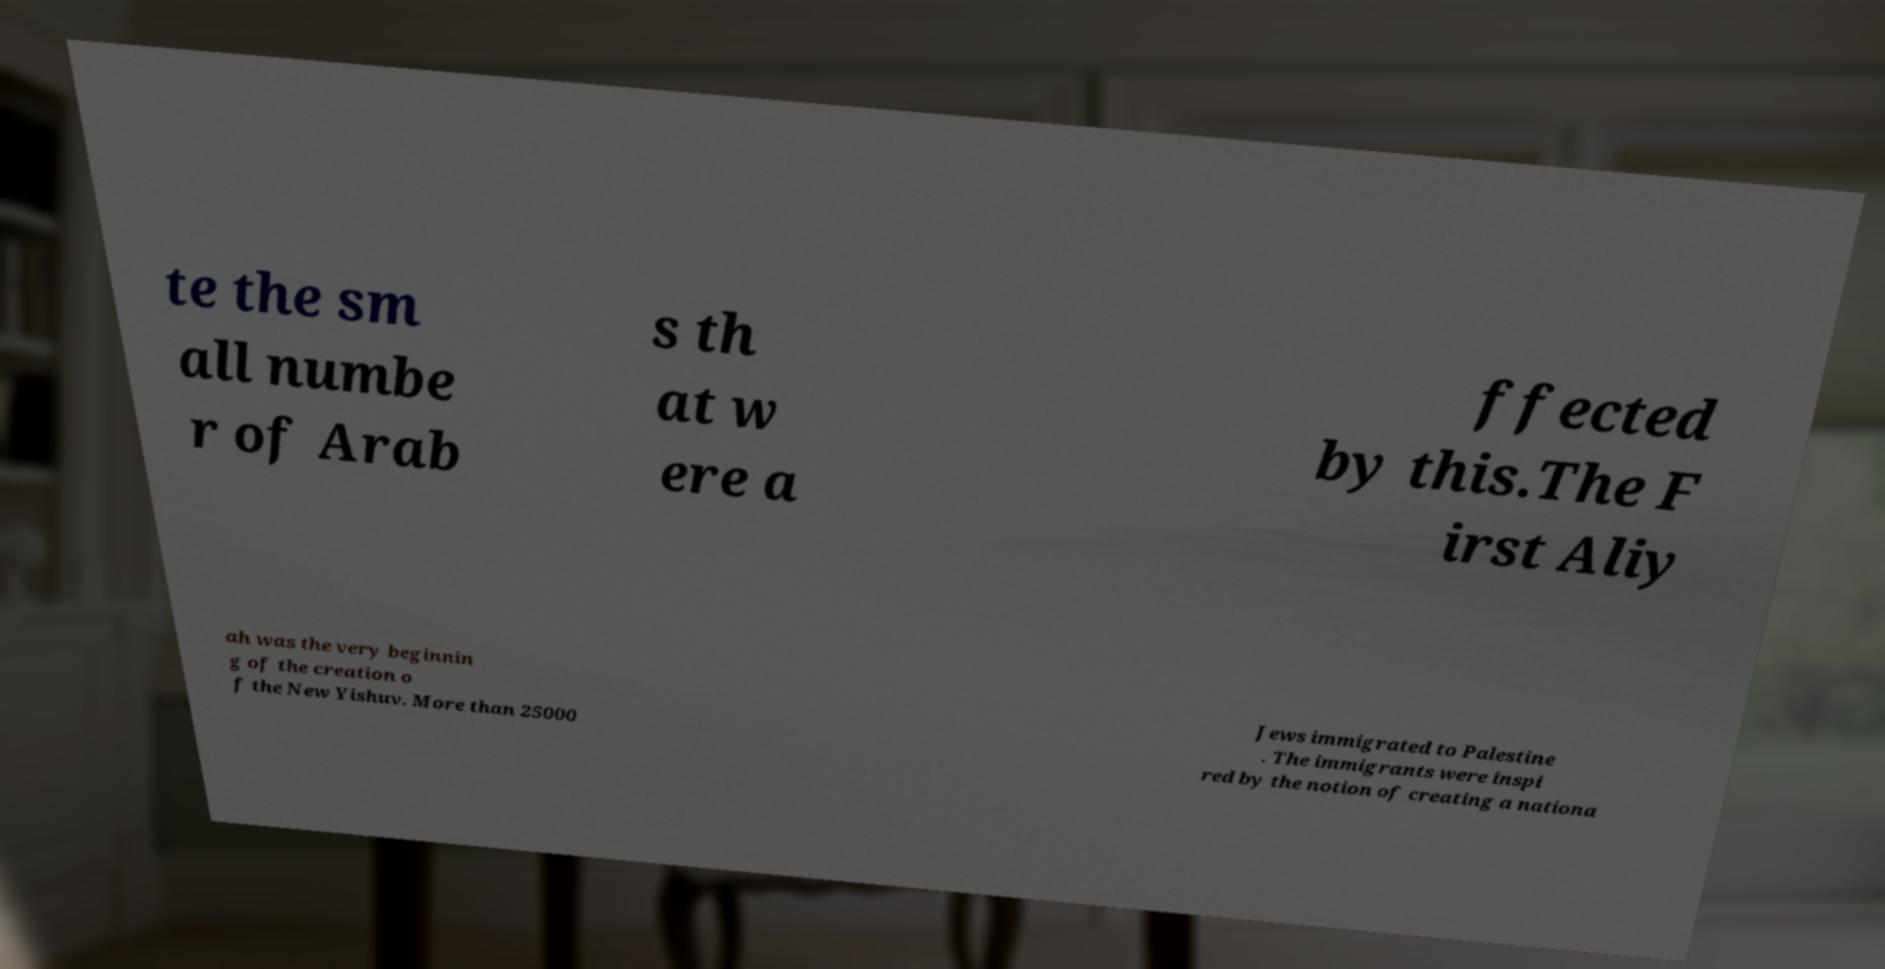There's text embedded in this image that I need extracted. Can you transcribe it verbatim? te the sm all numbe r of Arab s th at w ere a ffected by this.The F irst Aliy ah was the very beginnin g of the creation o f the New Yishuv. More than 25000 Jews immigrated to Palestine . The immigrants were inspi red by the notion of creating a nationa 